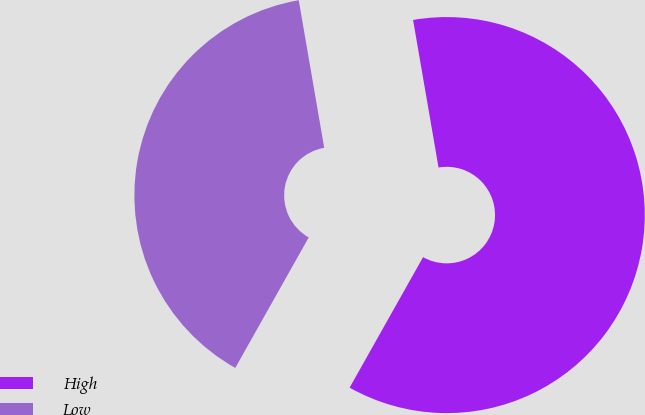Convert chart to OTSL. <chart><loc_0><loc_0><loc_500><loc_500><pie_chart><fcel>High<fcel>Low<nl><fcel>60.88%<fcel>39.12%<nl></chart> 